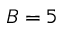<formula> <loc_0><loc_0><loc_500><loc_500>B = 5</formula> 